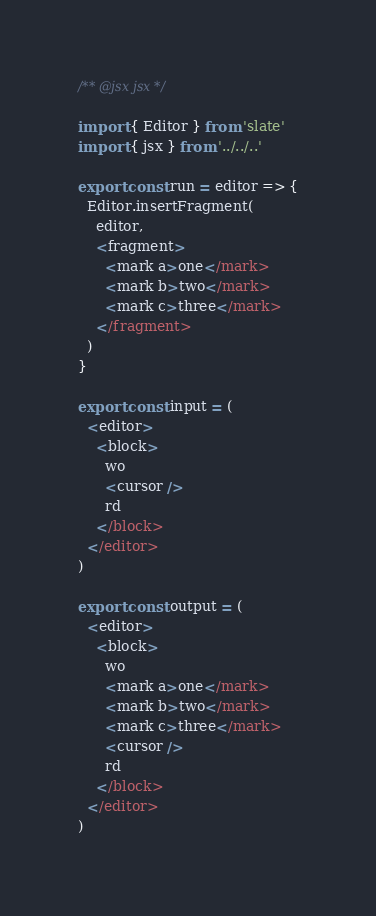<code> <loc_0><loc_0><loc_500><loc_500><_JavaScript_>/** @jsx jsx */

import { Editor } from 'slate'
import { jsx } from '../../..'

export const run = editor => {
  Editor.insertFragment(
    editor,
    <fragment>
      <mark a>one</mark>
      <mark b>two</mark>
      <mark c>three</mark>
    </fragment>
  )
}

export const input = (
  <editor>
    <block>
      wo
      <cursor />
      rd
    </block>
  </editor>
)

export const output = (
  <editor>
    <block>
      wo
      <mark a>one</mark>
      <mark b>two</mark>
      <mark c>three</mark>
      <cursor />
      rd
    </block>
  </editor>
)
</code> 